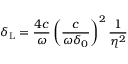Convert formula to latex. <formula><loc_0><loc_0><loc_500><loc_500>\delta _ { L } = \frac { 4 c } { \omega } \left ( \frac { c } { \omega \delta _ { 0 } } \right ) ^ { 2 } \frac { 1 } { \eta ^ { 2 } }</formula> 